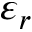Convert formula to latex. <formula><loc_0><loc_0><loc_500><loc_500>\varepsilon _ { r }</formula> 